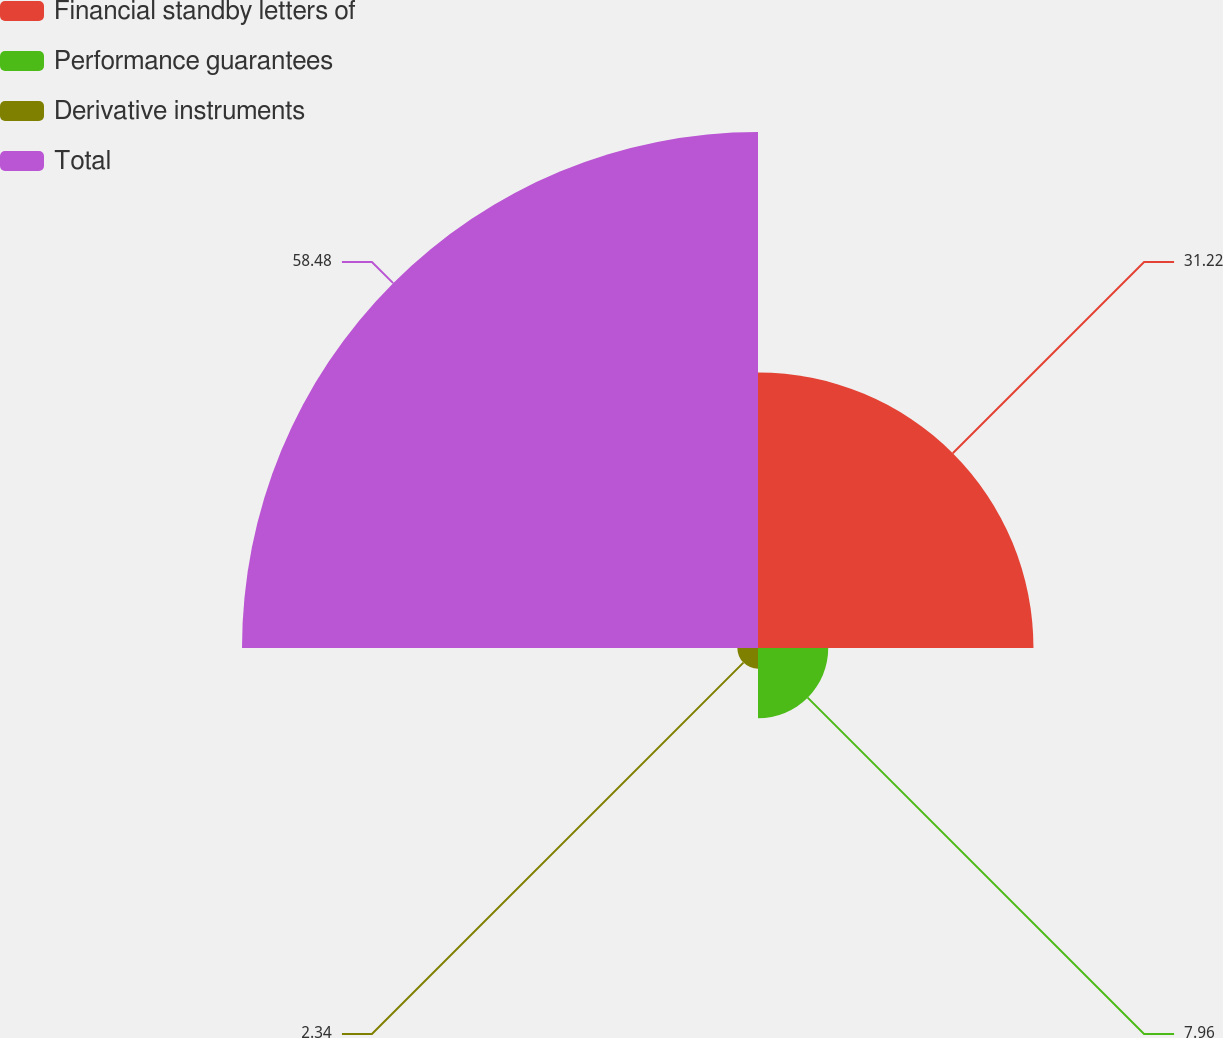Convert chart. <chart><loc_0><loc_0><loc_500><loc_500><pie_chart><fcel>Financial standby letters of<fcel>Performance guarantees<fcel>Derivative instruments<fcel>Total<nl><fcel>31.22%<fcel>7.96%<fcel>2.34%<fcel>58.48%<nl></chart> 